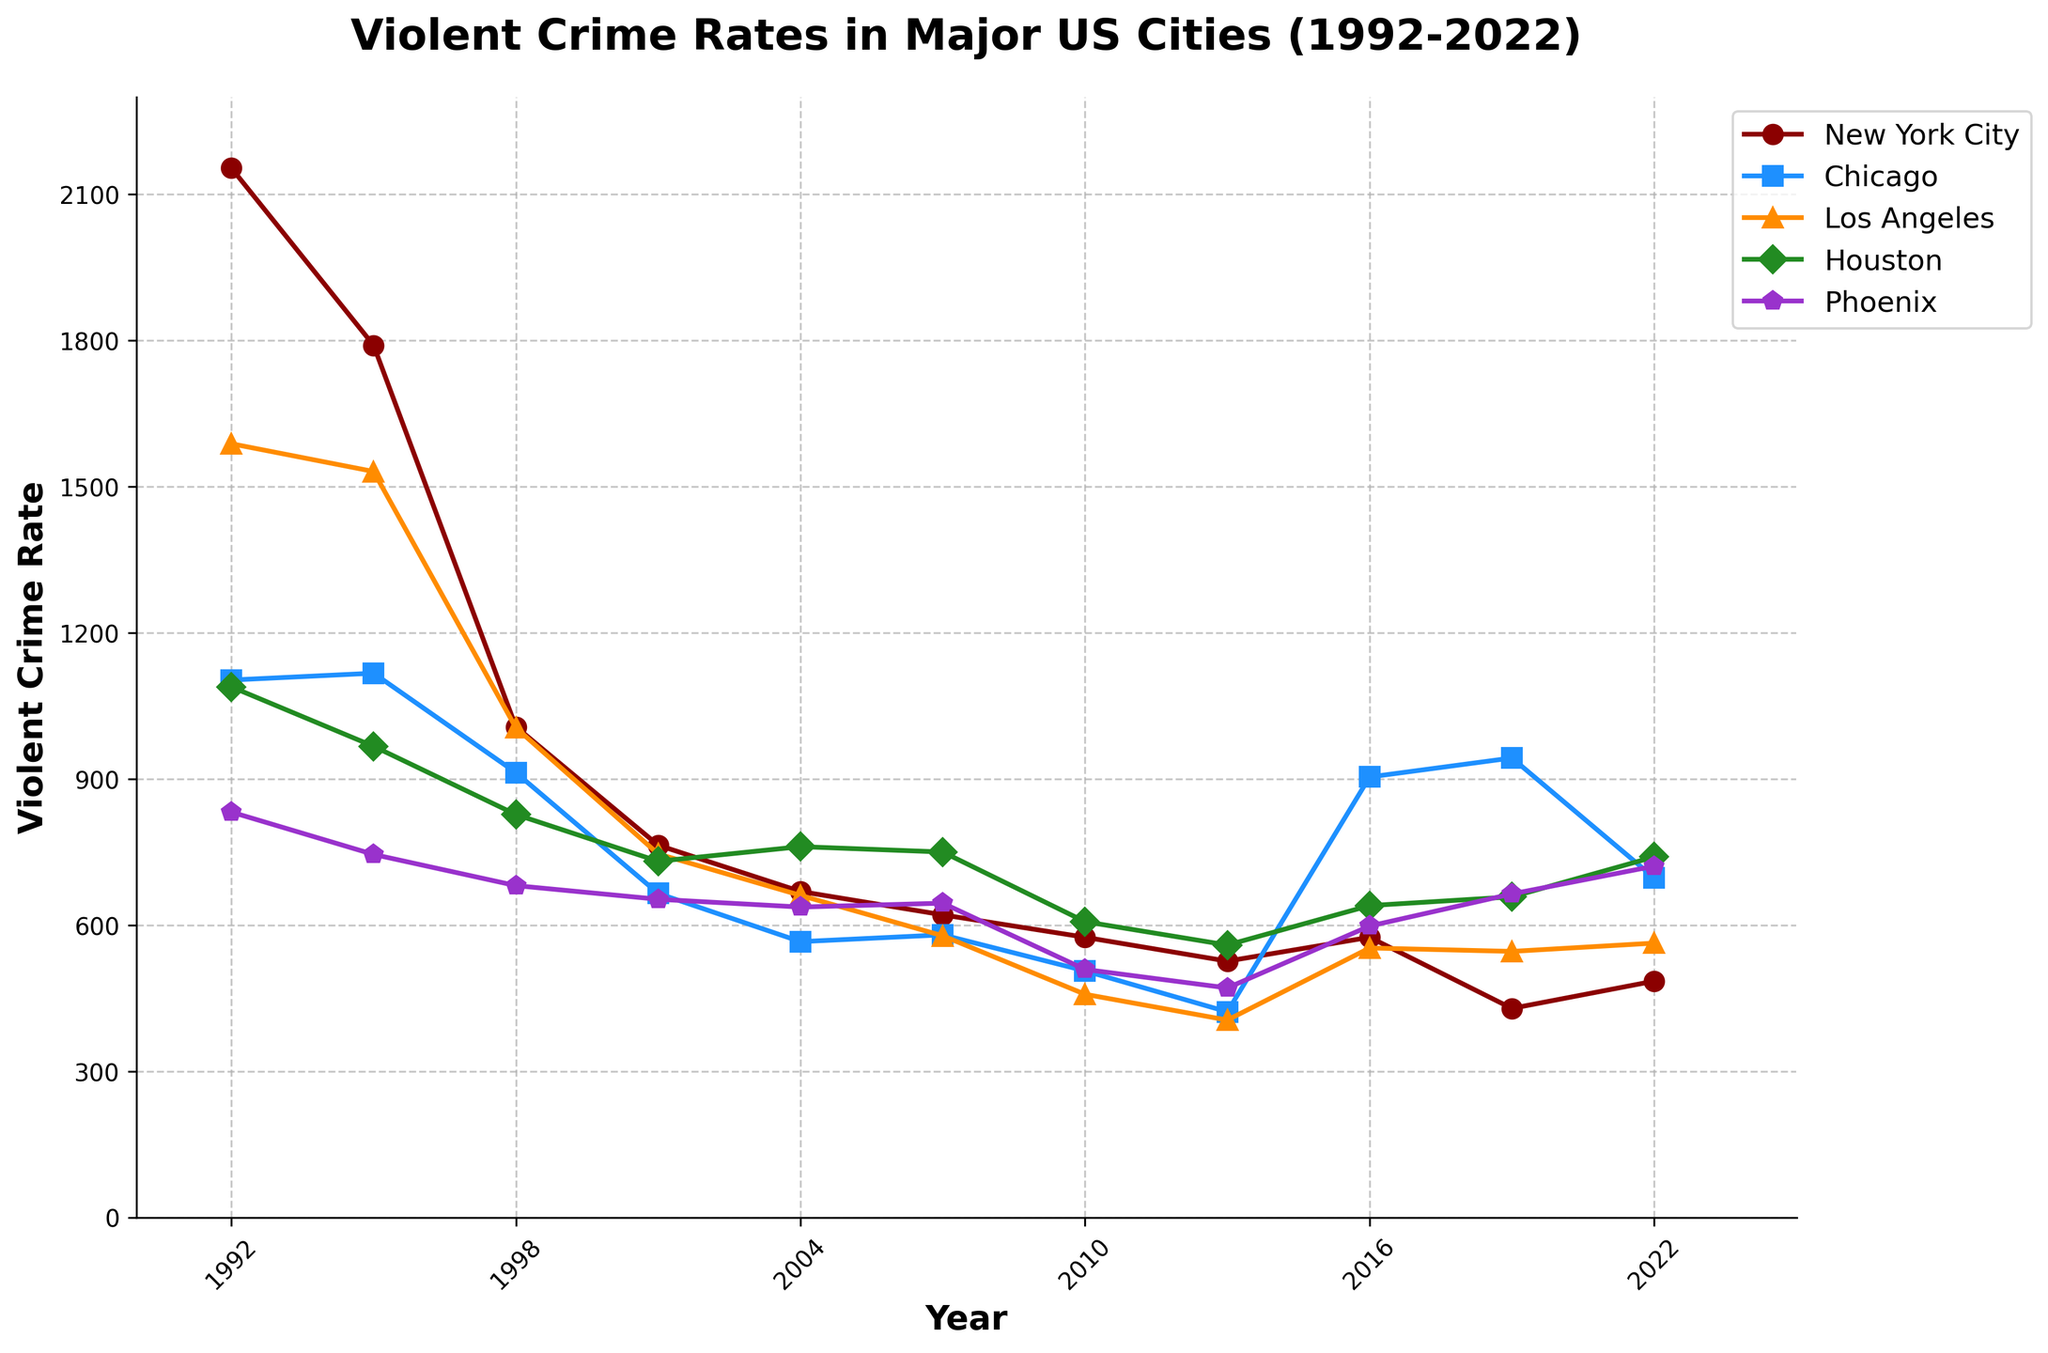Which city had the highest violent crime rate in 1992? Looking at the plot, the highest point for 1992 is for New York City.
Answer: New York City How did the violent crime rate change in Chicago from 1992 to 2022? In 1992, Chicago's rate is 1103. In 2022, it's 697. The change is a decrease of 1103 - 697 = 406.
Answer: Decreased by 406 Which city had the lowest violent crime rate in 2010, and what was it? Looking at the data points for 2010, Los Angeles has the lowest rate with a value of 458.
Answer: Los Angeles, 458 Is the violent crime rate in New York City in 2013 higher or lower compared to 2016? Inspecting the plot, New York City's rate in 2013 is 526, and in 2016 it's 575. Since 526 < 575, it’s lower in 2013.
Answer: Lower in 2013 Which city shows a significant increase in violent crime rate from 2010 to 2019? Chicago’s rate rises from 506 in 2010 to 943 in 2019. This period displays a sharp increase.
Answer: Chicago By how much did the violent crime rate in Houston change from 1995 to 2007? In 1995, Houston’s rate is 967. In 2007, it’s 750. Calculate the change as 967 - 750 = 217.
Answer: Decreased by 217 What years did Phoenix have a violent crime rate above 700? Scanning the plot, Phoenix’s rate exceeds 700 in 1992 and reappears above 700 in 2022.
Answer: 1992 and 2022 Which city had the smallest difference in violent crime rate between 2016 and 2019? Looking at the differences: New York City (575 - 429 = 146), Chicago (904 - 943 = -39), Los Angeles (553 - 546 = 7), Houston (640 - 658 = -18), and Phoenix (598 - 664 = -66). The smallest difference is in Los Angeles.
Answer: Los Angeles Which city’s violent crime rate remains mostly flat from 1998 to 2016? Houston's line from 1998 (827) to 2016 (640) shows less fluctuation compared to others, indicating a flatter trend.
Answer: Houston 